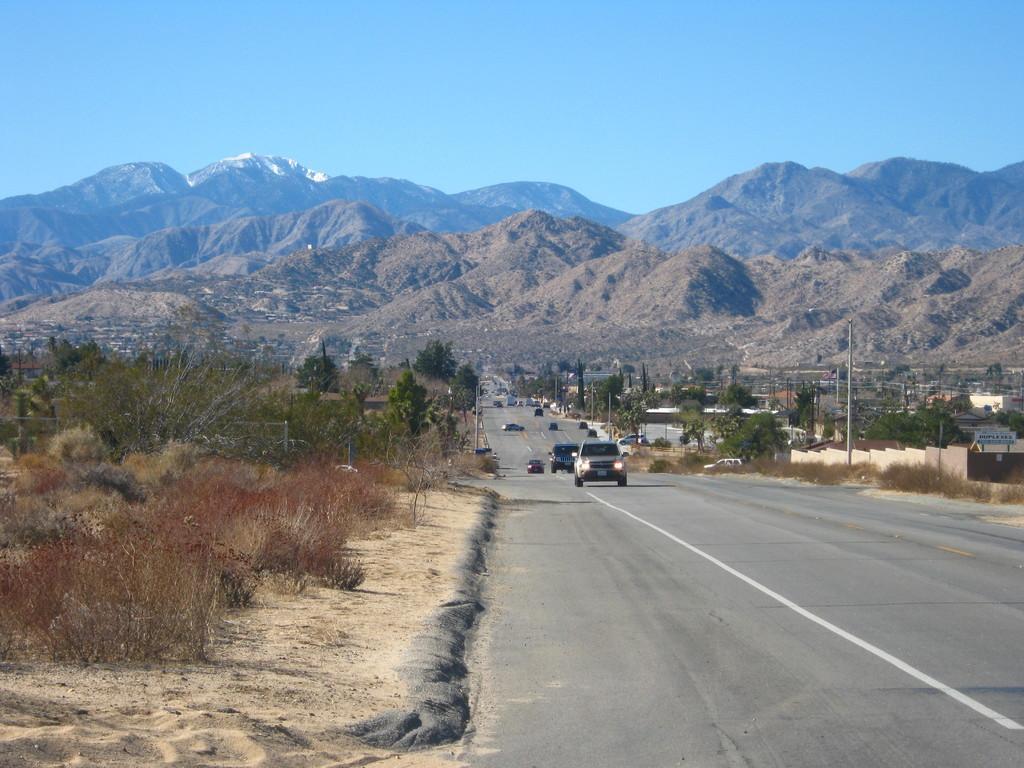How would you summarize this image in a sentence or two? In this image we can see motor vehicles on the road, poles, trees, bushes, hills, mountains and sky. 